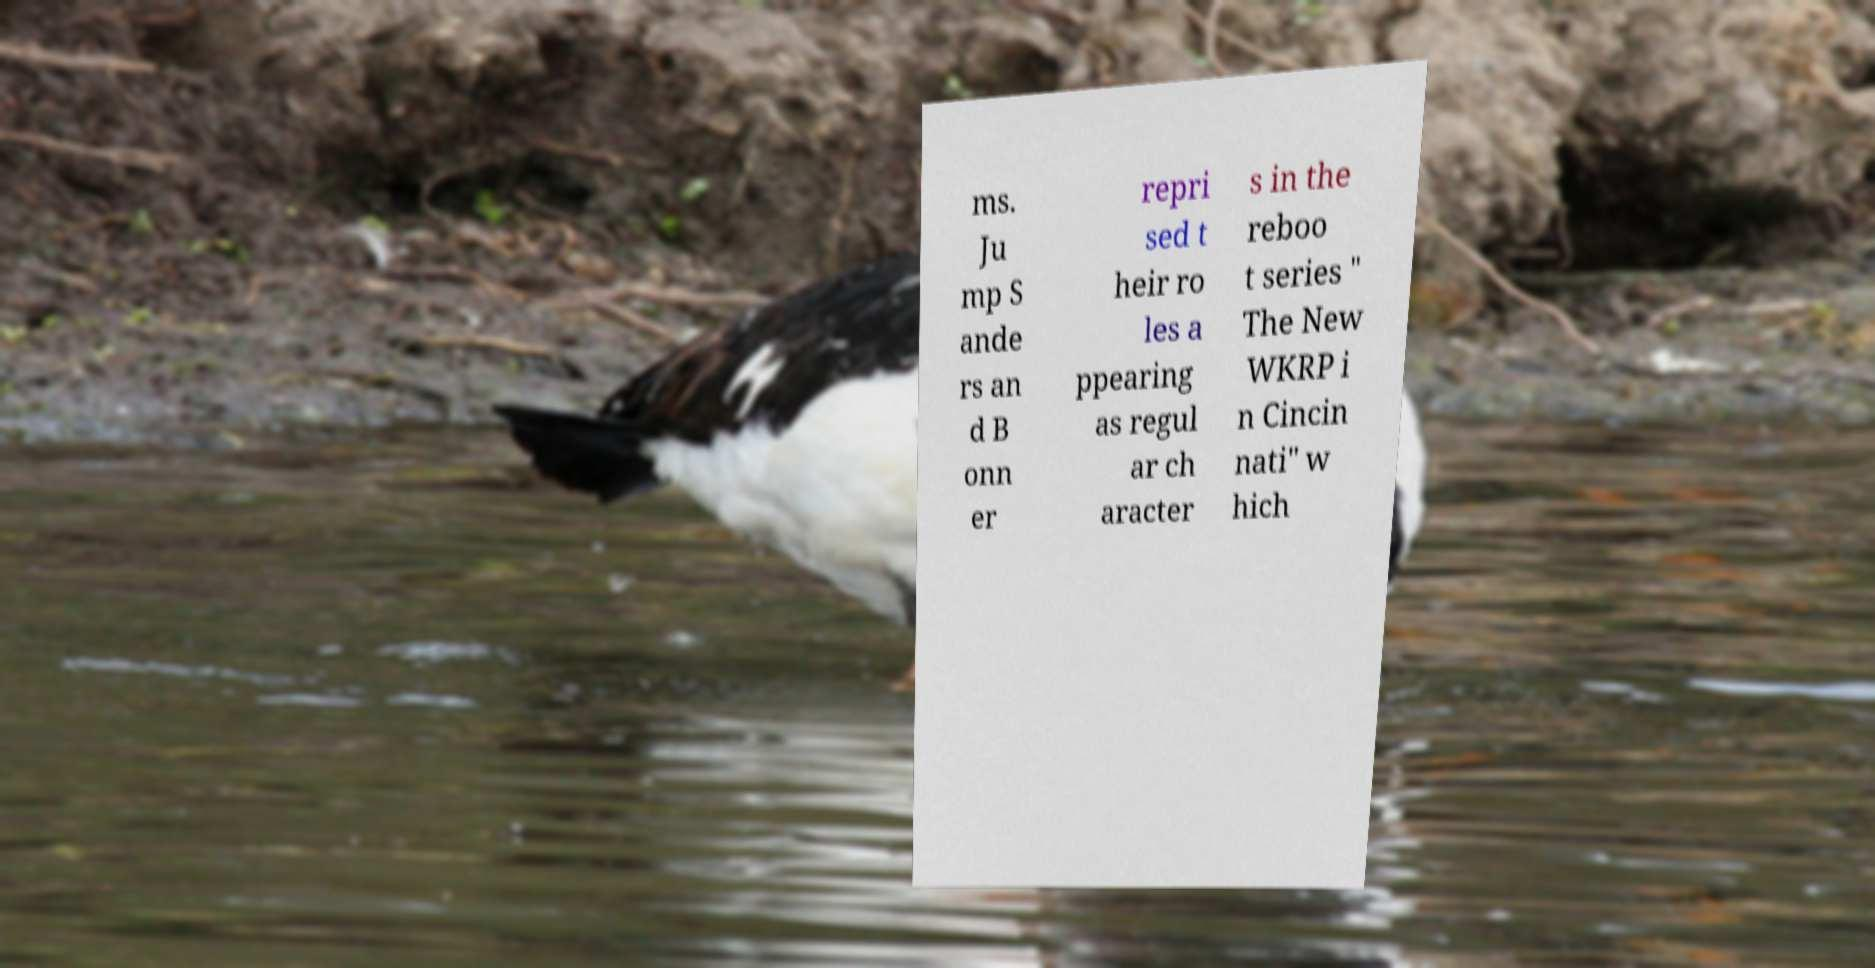Can you read and provide the text displayed in the image?This photo seems to have some interesting text. Can you extract and type it out for me? ms. Ju mp S ande rs an d B onn er repri sed t heir ro les a ppearing as regul ar ch aracter s in the reboo t series " The New WKRP i n Cincin nati" w hich 